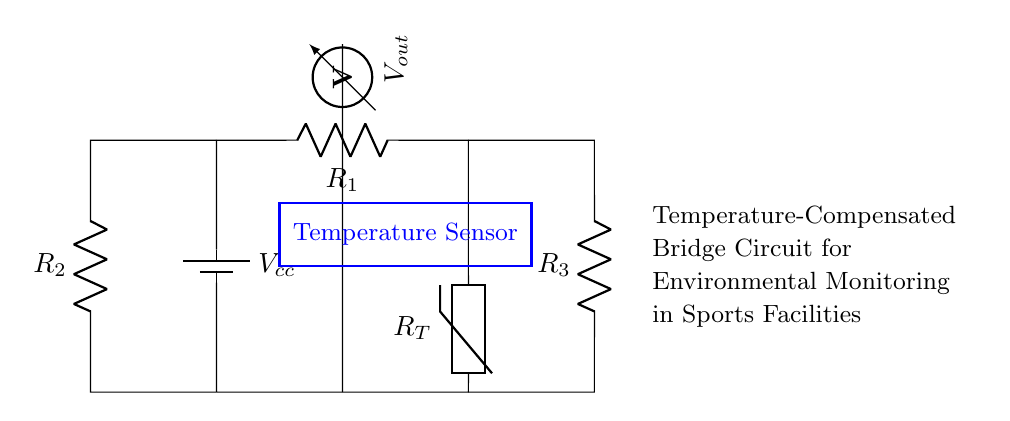What is the type of temperature sensor used in the circuit? The circuit includes a thermistor, which is a type of temperature sensor whose resistance changes with temperature.
Answer: thermistor What components form the voltage output? The voltage output is derived from the potential difference across the resistor labeled R1 and the thermistor, where their combined effects determine the output voltage.
Answer: R1 and R_T How many resistors are present in this bridge circuit? The circuit diagram shows three resistors: R1, R2, and R3, collectively used to balance the bridge.
Answer: three What is the purpose of the battery in this circuit? The battery provides the constant voltage supply (Vcc) necessary to power the circuit and enable the measurement across the components within the bridge configuration.
Answer: power supply How does the thermistor influence the output voltage? The thermistor’s resistance varies with temperature changes, which impacts the voltage divider effect created with R1, thus directly affecting the output voltage (Vout).
Answer: it alters Vout What is the relationship between R1 and R2 in the context of this bridge circuit? R1 and R2 are part of a voltage divider configuration; if R2 is used for balancing with R1, it helps stabilize the output voltage based on the temperature sensed.
Answer: they form a voltage divider What does the rectangle labeled "Temperature Sensor" indicate? The rectangle highlights the area that includes the thermistor and its functional relation to the environmental temperature measurement, illustrating its importance in the circuit's operation.
Answer: functional region of the thermistor 